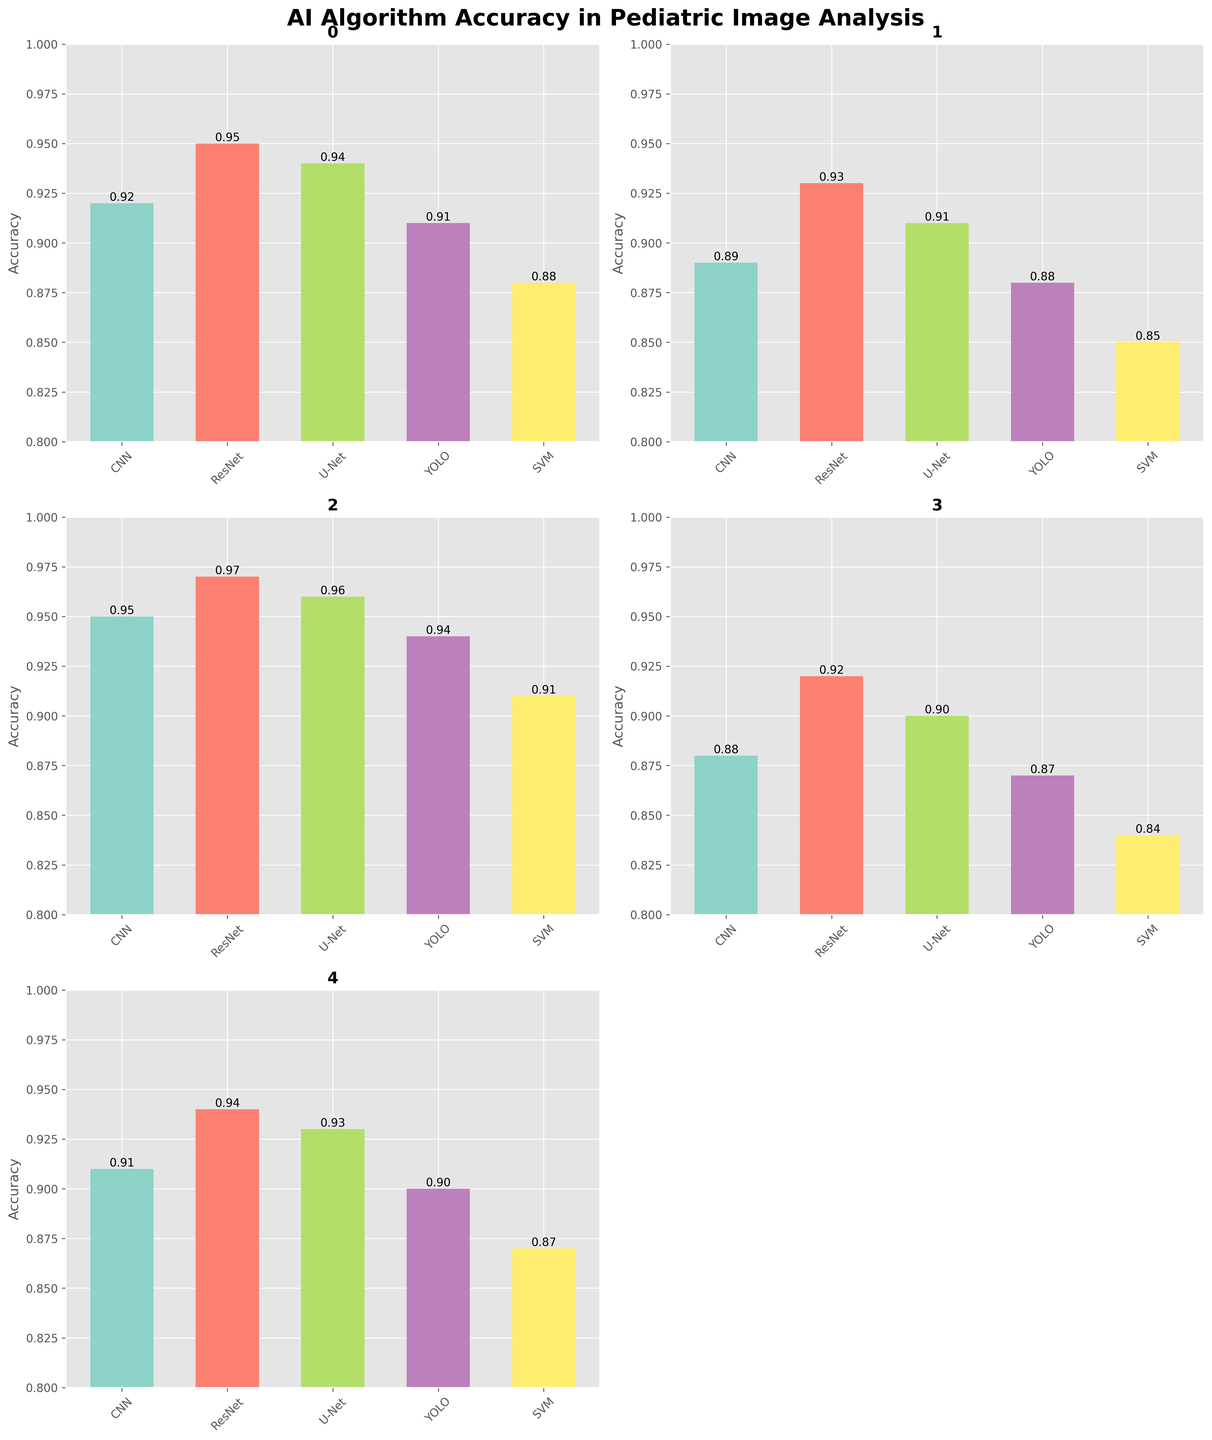Which AI algorithm shows the highest accuracy for Brain Tumor Detection? Look at the bar heights for Brain Tumor Detection and compare them. The highest bar corresponds to ResNet.
Answer: ResNet What is the difference in accuracy between the highest and lowest algorithms for Pneumonia Detection? Identify the highest and lowest bars for Pneumonia Detection. The highest accuracy is for ResNet (0.97) and the lowest is for SVM (0.91). The difference is 0.97 - 0.91.
Answer: 0.06 Which task has the smallest accuracy range (i.e., the difference between the highest and lowest accuracies)? Calculate the range for each task and compare. Brain Tumor Detection: 0.95 - 0.88 = 0.07, Bone Age Assessment: 0.93 - 0.85 = 0.08, Pneumonia Detection: 0.97 - 0.91 = 0.06, Congenital Heart Defects: 0.92 - 0.84 = 0.08, Retinopathy of Prematurity: 0.94 - 0.87 = 0.07. The smallest range is for Pneumonia Detection.
Answer: Pneumonia Detection Which task does U-Net perform better than CNN but worse than ResNet? Check the three algorithms (U-Net, CNN, ResNet) for each task. The task where U-Net's accuracy is between CNN and ResNet is Brain Tumor Detection: U-Net (0.94) is better than CNN (0.92) but worse than ResNet (0.95).
Answer: Brain Tumor Detection What is the average accuracy of YOLO across all tasks? Sum the YOLO accuracies for all tasks and divide by the number of tasks. (0.91 + 0.88 + 0.94 + 0.87 + 0.90) / 5 = 4.5 / 5.
Answer: 0.90 Which AI algorithm shows the most consistently high performance across different tasks? Count the number of times each algorithm is the highest or second-highest for each task. ResNet has the highest number of consistent high performances.
Answer: ResNet How does the accuracy of SVM for Bone Age Assessment compare to that of ResNet for the same task? Look at the respective bars for Bone Age Assessment. SVM has an accuracy of 0.85, while ResNet has 0.93. ResNet's accuracy is higher by 0.08.
Answer: ResNet is better by 0.08 Which algorithm has the lowest average accuracy across all tasks? Calculate the average accuracy for each algorithm across all tasks and compare them. SVM's averages are: (0.88 + 0.85 + 0.91 + 0.84 + 0.87)/5 = 0.87, which is the lowest.
Answer: SVM Which task has the highest maximum accuracy across all algorithms? Identify the highest accuracy for each task and compare them. The highest value among those maximums is 0.97 for Pneumonia Detection.
Answer: Pneumonia Detection In how many tasks is CNN the second most accurate algorithm? Check each task to see where CNN is the second highest. CNN is second in Brain Tumor Detection (0.92), Pneumonia Detection (0.95), and Retinopathy of Prematurity (0.91). That totals 3 tasks.
Answer: 3 